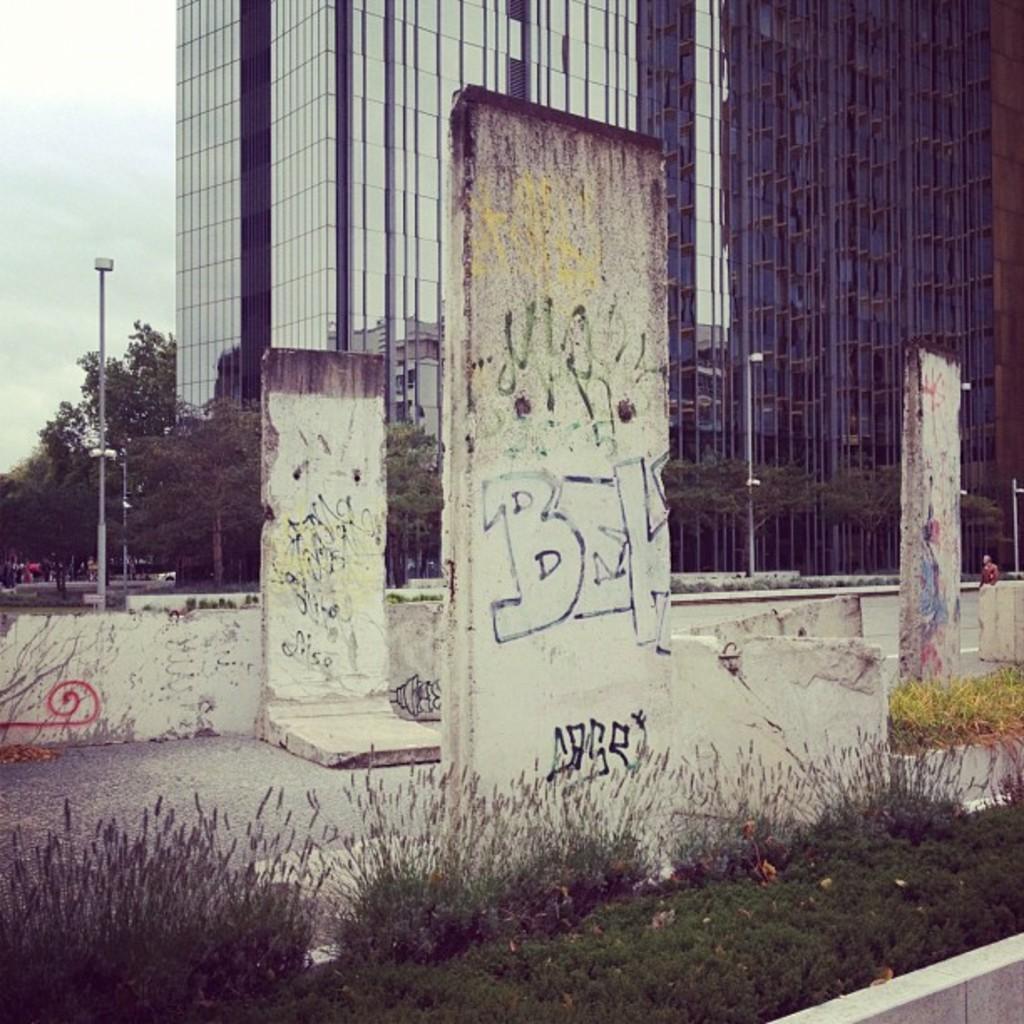Can you describe this image briefly? Graffiti is on stones. In-front of these stones there are plants and grass. Background we can see building, trees and light poles. To this building there are glass windows. 